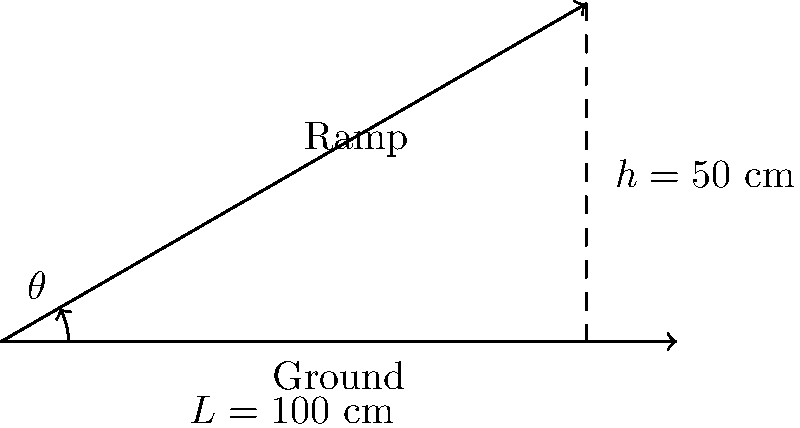As the principal overseeing the construction of a new accessible entrance, you need to ensure the ramp meets ADA standards. The ramp needs to rise 50 cm over a horizontal distance of 100 cm. What is the optimal angle $\theta$ for the ramp to meet accessibility standards while promoting both safety and independence for student athletes? To solve this problem, we'll follow these steps:

1) First, recall that the ADA (Americans with Disabilities Act) recommends a maximum slope of 1:12 for ramps, which is equivalent to an angle of approximately 4.8°. However, the optimal angle should balance accessibility with space constraints.

2) We can calculate the angle using trigonometry. We have a right triangle where:
   - The opposite side (height) is 50 cm
   - The adjacent side (horizontal distance) is 100 cm

3) To find the angle, we use the arctangent function:

   $\theta = \arctan(\frac{\text{opposite}}{\text{adjacent}}) = \arctan(\frac{50}{100})$

4) Simplifying:
   $\theta = \arctan(0.5)$

5) Using a calculator or trigonometric tables:
   $\theta \approx 26.57°$

6) This angle is steeper than the ADA recommendation, but it may be necessary due to space constraints. It's important to consider that while this angle meets the given specifications, it might be challenging for some individuals with mobility issues.

7) To promote both safety and independence for student athletes, consider:
   - Installing handrails on both sides of the ramp
   - Using a non-slip surface material
   - Ensuring proper lighting
   - Providing landings for rest at regular intervals if the ramp is long

8) While this angle is mathematically correct for the given dimensions, in practice, you might want to explore options for a gentler slope if space allows, to better accommodate all users.
Answer: $26.57°$ 